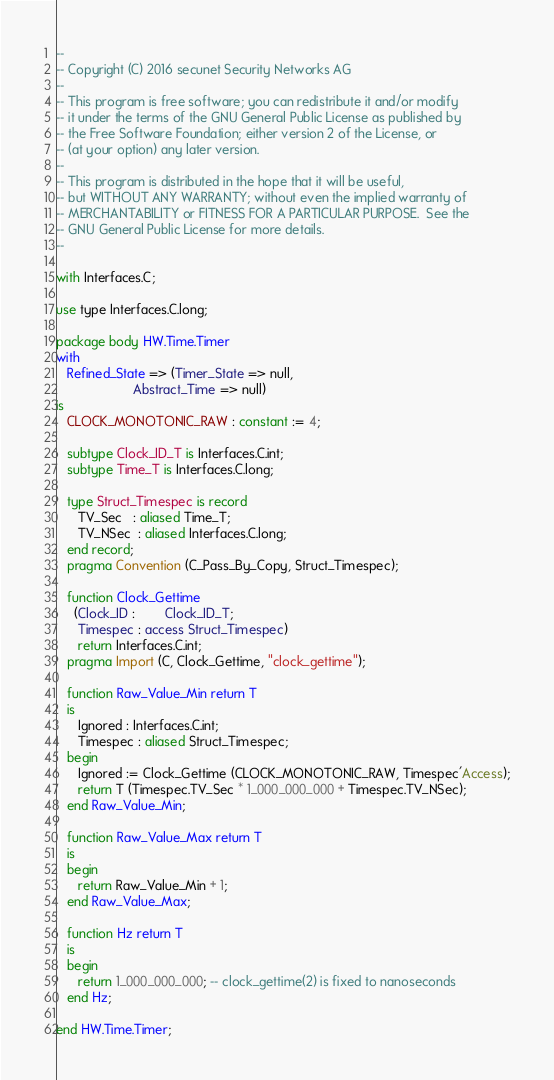<code> <loc_0><loc_0><loc_500><loc_500><_Ada_>--
-- Copyright (C) 2016 secunet Security Networks AG
--
-- This program is free software; you can redistribute it and/or modify
-- it under the terms of the GNU General Public License as published by
-- the Free Software Foundation; either version 2 of the License, or
-- (at your option) any later version.
--
-- This program is distributed in the hope that it will be useful,
-- but WITHOUT ANY WARRANTY; without even the implied warranty of
-- MERCHANTABILITY or FITNESS FOR A PARTICULAR PURPOSE.  See the
-- GNU General Public License for more details.
--

with Interfaces.C;

use type Interfaces.C.long;

package body HW.Time.Timer
with
   Refined_State => (Timer_State => null,
                     Abstract_Time => null)
is
   CLOCK_MONOTONIC_RAW : constant := 4;

   subtype Clock_ID_T is Interfaces.C.int;
   subtype Time_T is Interfaces.C.long;

   type Struct_Timespec is record
      TV_Sec   : aliased Time_T;
      TV_NSec  : aliased Interfaces.C.long;
   end record;
   pragma Convention (C_Pass_By_Copy, Struct_Timespec);

   function Clock_Gettime
     (Clock_ID :        Clock_ID_T;
      Timespec : access Struct_Timespec)
      return Interfaces.C.int;
   pragma Import (C, Clock_Gettime, "clock_gettime");

   function Raw_Value_Min return T
   is
      Ignored : Interfaces.C.int;
      Timespec : aliased Struct_Timespec;
   begin
      Ignored := Clock_Gettime (CLOCK_MONOTONIC_RAW, Timespec'Access);
      return T (Timespec.TV_Sec * 1_000_000_000 + Timespec.TV_NSec);
   end Raw_Value_Min;

   function Raw_Value_Max return T
   is
   begin
      return Raw_Value_Min + 1;
   end Raw_Value_Max;

   function Hz return T
   is
   begin
      return 1_000_000_000; -- clock_gettime(2) is fixed to nanoseconds
   end Hz;

end HW.Time.Timer;
</code> 